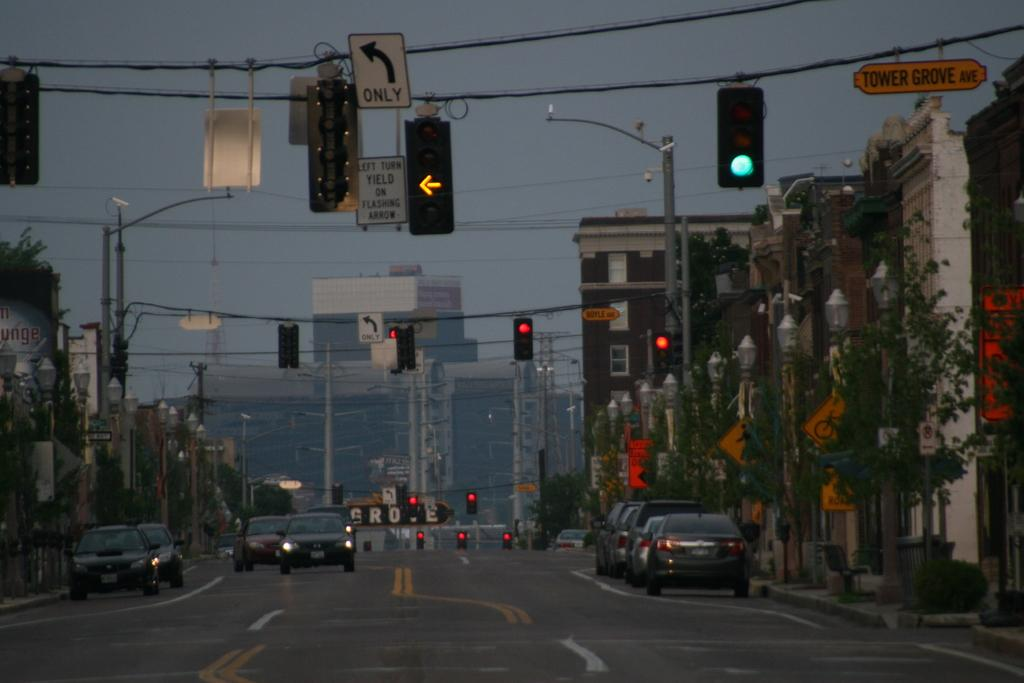<image>
Write a terse but informative summary of the picture. An intersection with a yellow left turn arrow and a sign that says left turn yield on flashing arrow. 